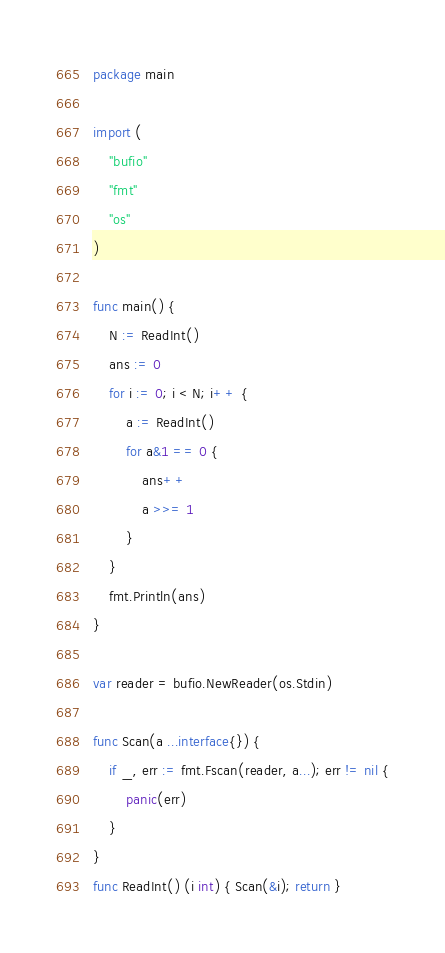<code> <loc_0><loc_0><loc_500><loc_500><_Go_>package main

import (
	"bufio"
	"fmt"
	"os"
)

func main() {
	N := ReadInt()
	ans := 0
	for i := 0; i < N; i++ {
		a := ReadInt()
		for a&1 == 0 {
			ans++
			a >>= 1
		}
	}
	fmt.Println(ans)
}

var reader = bufio.NewReader(os.Stdin)

func Scan(a ...interface{}) {
	if _, err := fmt.Fscan(reader, a...); err != nil {
		panic(err)
	}
}
func ReadInt() (i int) { Scan(&i); return }
</code> 